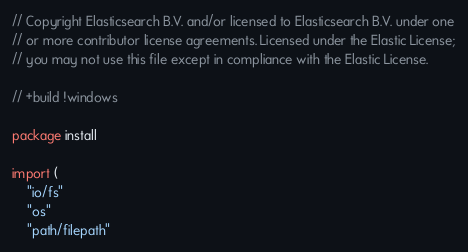Convert code to text. <code><loc_0><loc_0><loc_500><loc_500><_Go_>// Copyright Elasticsearch B.V. and/or licensed to Elasticsearch B.V. under one
// or more contributor license agreements. Licensed under the Elastic License;
// you may not use this file except in compliance with the Elastic License.

// +build !windows

package install

import (
	"io/fs"
	"os"
	"path/filepath"
</code> 